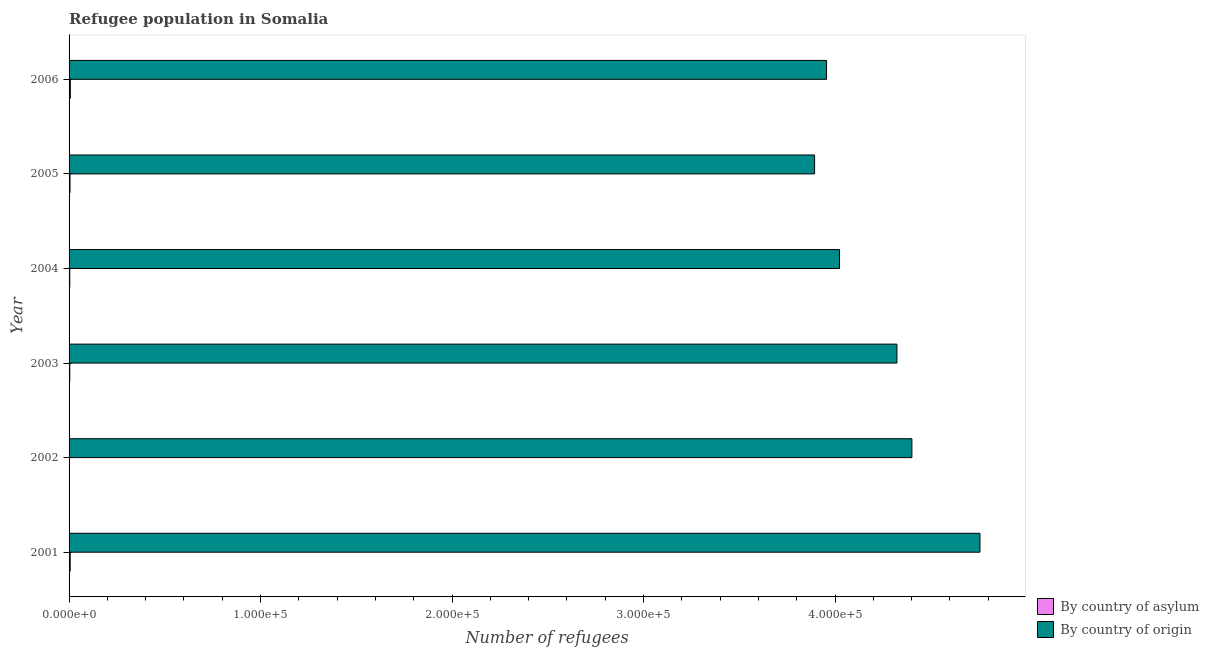How many different coloured bars are there?
Your response must be concise. 2. How many groups of bars are there?
Offer a terse response. 6. How many bars are there on the 3rd tick from the bottom?
Ensure brevity in your answer.  2. What is the label of the 5th group of bars from the top?
Provide a succinct answer. 2002. What is the number of refugees by country of asylum in 2006?
Offer a terse response. 669. Across all years, what is the maximum number of refugees by country of asylum?
Provide a succinct answer. 669. Across all years, what is the minimum number of refugees by country of origin?
Make the answer very short. 3.89e+05. What is the total number of refugees by country of asylum in the graph?
Provide a short and direct response. 2675. What is the difference between the number of refugees by country of origin in 2002 and that in 2006?
Your answer should be compact. 4.46e+04. What is the difference between the number of refugees by country of origin in 2002 and the number of refugees by country of asylum in 2001?
Your answer should be compact. 4.40e+05. What is the average number of refugees by country of asylum per year?
Your answer should be very brief. 445.83. In the year 2001, what is the difference between the number of refugees by country of asylum and number of refugees by country of origin?
Give a very brief answer. -4.75e+05. In how many years, is the number of refugees by country of origin greater than 240000 ?
Offer a very short reply. 6. What is the ratio of the number of refugees by country of asylum in 2002 to that in 2005?
Offer a very short reply. 0.4. Is the difference between the number of refugees by country of asylum in 2003 and 2006 greater than the difference between the number of refugees by country of origin in 2003 and 2006?
Make the answer very short. No. What is the difference between the highest and the second highest number of refugees by country of origin?
Give a very brief answer. 3.55e+04. What is the difference between the highest and the lowest number of refugees by country of asylum?
Offer a very short reply. 470. In how many years, is the number of refugees by country of origin greater than the average number of refugees by country of origin taken over all years?
Give a very brief answer. 3. What does the 1st bar from the top in 2004 represents?
Your answer should be very brief. By country of origin. What does the 1st bar from the bottom in 2001 represents?
Your answer should be compact. By country of asylum. How many bars are there?
Provide a succinct answer. 12. How many years are there in the graph?
Make the answer very short. 6. Are the values on the major ticks of X-axis written in scientific E-notation?
Make the answer very short. Yes. Does the graph contain any zero values?
Provide a succinct answer. No. Does the graph contain grids?
Give a very brief answer. No. Where does the legend appear in the graph?
Offer a terse response. Bottom right. How are the legend labels stacked?
Provide a succinct answer. Vertical. What is the title of the graph?
Your answer should be compact. Refugee population in Somalia. Does "Boys" appear as one of the legend labels in the graph?
Offer a terse response. No. What is the label or title of the X-axis?
Offer a terse response. Number of refugees. What is the Number of refugees of By country of asylum in 2001?
Your response must be concise. 589. What is the Number of refugees of By country of origin in 2001?
Keep it short and to the point. 4.76e+05. What is the Number of refugees in By country of asylum in 2002?
Your response must be concise. 199. What is the Number of refugees of By country of origin in 2002?
Your response must be concise. 4.40e+05. What is the Number of refugees in By country of asylum in 2003?
Ensure brevity in your answer.  368. What is the Number of refugees in By country of origin in 2003?
Ensure brevity in your answer.  4.32e+05. What is the Number of refugees of By country of asylum in 2004?
Make the answer very short. 357. What is the Number of refugees in By country of origin in 2004?
Give a very brief answer. 4.02e+05. What is the Number of refugees in By country of asylum in 2005?
Your answer should be compact. 493. What is the Number of refugees of By country of origin in 2005?
Provide a short and direct response. 3.89e+05. What is the Number of refugees of By country of asylum in 2006?
Make the answer very short. 669. What is the Number of refugees in By country of origin in 2006?
Ensure brevity in your answer.  3.96e+05. Across all years, what is the maximum Number of refugees in By country of asylum?
Your response must be concise. 669. Across all years, what is the maximum Number of refugees in By country of origin?
Your answer should be compact. 4.76e+05. Across all years, what is the minimum Number of refugees of By country of asylum?
Your answer should be compact. 199. Across all years, what is the minimum Number of refugees in By country of origin?
Offer a terse response. 3.89e+05. What is the total Number of refugees in By country of asylum in the graph?
Your answer should be very brief. 2675. What is the total Number of refugees in By country of origin in the graph?
Ensure brevity in your answer.  2.54e+06. What is the difference between the Number of refugees of By country of asylum in 2001 and that in 2002?
Your response must be concise. 390. What is the difference between the Number of refugees of By country of origin in 2001 and that in 2002?
Offer a terse response. 3.55e+04. What is the difference between the Number of refugees of By country of asylum in 2001 and that in 2003?
Give a very brief answer. 221. What is the difference between the Number of refugees in By country of origin in 2001 and that in 2003?
Provide a succinct answer. 4.33e+04. What is the difference between the Number of refugees in By country of asylum in 2001 and that in 2004?
Your answer should be compact. 232. What is the difference between the Number of refugees of By country of origin in 2001 and that in 2004?
Offer a terse response. 7.33e+04. What is the difference between the Number of refugees of By country of asylum in 2001 and that in 2005?
Provide a succinct answer. 96. What is the difference between the Number of refugees of By country of origin in 2001 and that in 2005?
Provide a short and direct response. 8.63e+04. What is the difference between the Number of refugees in By country of asylum in 2001 and that in 2006?
Ensure brevity in your answer.  -80. What is the difference between the Number of refugees of By country of origin in 2001 and that in 2006?
Provide a short and direct response. 8.01e+04. What is the difference between the Number of refugees in By country of asylum in 2002 and that in 2003?
Give a very brief answer. -169. What is the difference between the Number of refugees of By country of origin in 2002 and that in 2003?
Provide a succinct answer. 7818. What is the difference between the Number of refugees of By country of asylum in 2002 and that in 2004?
Provide a succinct answer. -158. What is the difference between the Number of refugees of By country of origin in 2002 and that in 2004?
Ensure brevity in your answer.  3.78e+04. What is the difference between the Number of refugees in By country of asylum in 2002 and that in 2005?
Provide a short and direct response. -294. What is the difference between the Number of refugees in By country of origin in 2002 and that in 2005?
Your answer should be compact. 5.08e+04. What is the difference between the Number of refugees of By country of asylum in 2002 and that in 2006?
Offer a very short reply. -470. What is the difference between the Number of refugees of By country of origin in 2002 and that in 2006?
Ensure brevity in your answer.  4.46e+04. What is the difference between the Number of refugees of By country of origin in 2003 and that in 2004?
Your answer should be compact. 3.00e+04. What is the difference between the Number of refugees in By country of asylum in 2003 and that in 2005?
Your answer should be compact. -125. What is the difference between the Number of refugees of By country of origin in 2003 and that in 2005?
Provide a short and direct response. 4.30e+04. What is the difference between the Number of refugees of By country of asylum in 2003 and that in 2006?
Provide a short and direct response. -301. What is the difference between the Number of refugees in By country of origin in 2003 and that in 2006?
Keep it short and to the point. 3.68e+04. What is the difference between the Number of refugees of By country of asylum in 2004 and that in 2005?
Your response must be concise. -136. What is the difference between the Number of refugees of By country of origin in 2004 and that in 2005?
Offer a very short reply. 1.30e+04. What is the difference between the Number of refugees of By country of asylum in 2004 and that in 2006?
Offer a terse response. -312. What is the difference between the Number of refugees in By country of origin in 2004 and that in 2006?
Provide a short and direct response. 6783. What is the difference between the Number of refugees in By country of asylum in 2005 and that in 2006?
Provide a succinct answer. -176. What is the difference between the Number of refugees in By country of origin in 2005 and that in 2006?
Offer a terse response. -6239. What is the difference between the Number of refugees in By country of asylum in 2001 and the Number of refugees in By country of origin in 2002?
Give a very brief answer. -4.40e+05. What is the difference between the Number of refugees of By country of asylum in 2001 and the Number of refugees of By country of origin in 2003?
Offer a very short reply. -4.32e+05. What is the difference between the Number of refugees in By country of asylum in 2001 and the Number of refugees in By country of origin in 2004?
Provide a succinct answer. -4.02e+05. What is the difference between the Number of refugees in By country of asylum in 2001 and the Number of refugees in By country of origin in 2005?
Your answer should be very brief. -3.89e+05. What is the difference between the Number of refugees in By country of asylum in 2001 and the Number of refugees in By country of origin in 2006?
Provide a short and direct response. -3.95e+05. What is the difference between the Number of refugees in By country of asylum in 2002 and the Number of refugees in By country of origin in 2003?
Your response must be concise. -4.32e+05. What is the difference between the Number of refugees of By country of asylum in 2002 and the Number of refugees of By country of origin in 2004?
Give a very brief answer. -4.02e+05. What is the difference between the Number of refugees in By country of asylum in 2002 and the Number of refugees in By country of origin in 2005?
Offer a terse response. -3.89e+05. What is the difference between the Number of refugees of By country of asylum in 2002 and the Number of refugees of By country of origin in 2006?
Provide a short and direct response. -3.95e+05. What is the difference between the Number of refugees of By country of asylum in 2003 and the Number of refugees of By country of origin in 2004?
Provide a short and direct response. -4.02e+05. What is the difference between the Number of refugees in By country of asylum in 2003 and the Number of refugees in By country of origin in 2005?
Give a very brief answer. -3.89e+05. What is the difference between the Number of refugees in By country of asylum in 2003 and the Number of refugees in By country of origin in 2006?
Keep it short and to the point. -3.95e+05. What is the difference between the Number of refugees in By country of asylum in 2004 and the Number of refugees in By country of origin in 2005?
Make the answer very short. -3.89e+05. What is the difference between the Number of refugees of By country of asylum in 2004 and the Number of refugees of By country of origin in 2006?
Provide a short and direct response. -3.95e+05. What is the difference between the Number of refugees in By country of asylum in 2005 and the Number of refugees in By country of origin in 2006?
Keep it short and to the point. -3.95e+05. What is the average Number of refugees of By country of asylum per year?
Provide a succinct answer. 445.83. What is the average Number of refugees of By country of origin per year?
Provide a short and direct response. 4.23e+05. In the year 2001, what is the difference between the Number of refugees in By country of asylum and Number of refugees in By country of origin?
Offer a very short reply. -4.75e+05. In the year 2002, what is the difference between the Number of refugees in By country of asylum and Number of refugees in By country of origin?
Provide a succinct answer. -4.40e+05. In the year 2003, what is the difference between the Number of refugees of By country of asylum and Number of refugees of By country of origin?
Your answer should be compact. -4.32e+05. In the year 2004, what is the difference between the Number of refugees in By country of asylum and Number of refugees in By country of origin?
Make the answer very short. -4.02e+05. In the year 2005, what is the difference between the Number of refugees in By country of asylum and Number of refugees in By country of origin?
Ensure brevity in your answer.  -3.89e+05. In the year 2006, what is the difference between the Number of refugees of By country of asylum and Number of refugees of By country of origin?
Your answer should be compact. -3.95e+05. What is the ratio of the Number of refugees in By country of asylum in 2001 to that in 2002?
Provide a short and direct response. 2.96. What is the ratio of the Number of refugees in By country of origin in 2001 to that in 2002?
Provide a short and direct response. 1.08. What is the ratio of the Number of refugees of By country of asylum in 2001 to that in 2003?
Your response must be concise. 1.6. What is the ratio of the Number of refugees of By country of origin in 2001 to that in 2003?
Offer a very short reply. 1.1. What is the ratio of the Number of refugees of By country of asylum in 2001 to that in 2004?
Offer a terse response. 1.65. What is the ratio of the Number of refugees in By country of origin in 2001 to that in 2004?
Ensure brevity in your answer.  1.18. What is the ratio of the Number of refugees in By country of asylum in 2001 to that in 2005?
Offer a very short reply. 1.19. What is the ratio of the Number of refugees in By country of origin in 2001 to that in 2005?
Your answer should be very brief. 1.22. What is the ratio of the Number of refugees in By country of asylum in 2001 to that in 2006?
Your response must be concise. 0.88. What is the ratio of the Number of refugees in By country of origin in 2001 to that in 2006?
Your answer should be very brief. 1.2. What is the ratio of the Number of refugees of By country of asylum in 2002 to that in 2003?
Your response must be concise. 0.54. What is the ratio of the Number of refugees of By country of origin in 2002 to that in 2003?
Offer a terse response. 1.02. What is the ratio of the Number of refugees of By country of asylum in 2002 to that in 2004?
Your response must be concise. 0.56. What is the ratio of the Number of refugees in By country of origin in 2002 to that in 2004?
Your answer should be very brief. 1.09. What is the ratio of the Number of refugees of By country of asylum in 2002 to that in 2005?
Your response must be concise. 0.4. What is the ratio of the Number of refugees in By country of origin in 2002 to that in 2005?
Provide a succinct answer. 1.13. What is the ratio of the Number of refugees of By country of asylum in 2002 to that in 2006?
Give a very brief answer. 0.3. What is the ratio of the Number of refugees of By country of origin in 2002 to that in 2006?
Ensure brevity in your answer.  1.11. What is the ratio of the Number of refugees in By country of asylum in 2003 to that in 2004?
Keep it short and to the point. 1.03. What is the ratio of the Number of refugees of By country of origin in 2003 to that in 2004?
Keep it short and to the point. 1.07. What is the ratio of the Number of refugees in By country of asylum in 2003 to that in 2005?
Provide a short and direct response. 0.75. What is the ratio of the Number of refugees in By country of origin in 2003 to that in 2005?
Provide a short and direct response. 1.11. What is the ratio of the Number of refugees of By country of asylum in 2003 to that in 2006?
Your response must be concise. 0.55. What is the ratio of the Number of refugees in By country of origin in 2003 to that in 2006?
Make the answer very short. 1.09. What is the ratio of the Number of refugees of By country of asylum in 2004 to that in 2005?
Ensure brevity in your answer.  0.72. What is the ratio of the Number of refugees of By country of origin in 2004 to that in 2005?
Ensure brevity in your answer.  1.03. What is the ratio of the Number of refugees in By country of asylum in 2004 to that in 2006?
Your response must be concise. 0.53. What is the ratio of the Number of refugees of By country of origin in 2004 to that in 2006?
Provide a short and direct response. 1.02. What is the ratio of the Number of refugees in By country of asylum in 2005 to that in 2006?
Give a very brief answer. 0.74. What is the ratio of the Number of refugees of By country of origin in 2005 to that in 2006?
Your answer should be compact. 0.98. What is the difference between the highest and the second highest Number of refugees in By country of asylum?
Keep it short and to the point. 80. What is the difference between the highest and the second highest Number of refugees in By country of origin?
Your answer should be very brief. 3.55e+04. What is the difference between the highest and the lowest Number of refugees of By country of asylum?
Provide a short and direct response. 470. What is the difference between the highest and the lowest Number of refugees of By country of origin?
Offer a terse response. 8.63e+04. 